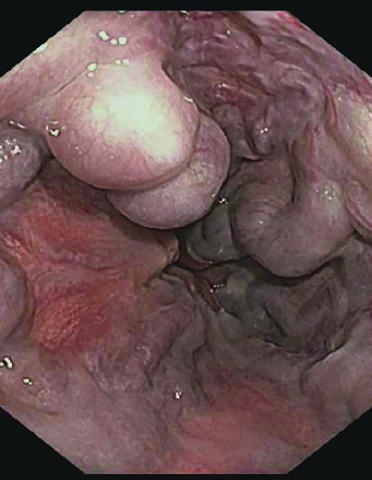s the angiogram striking?
Answer the question using a single word or phrase. Yes 